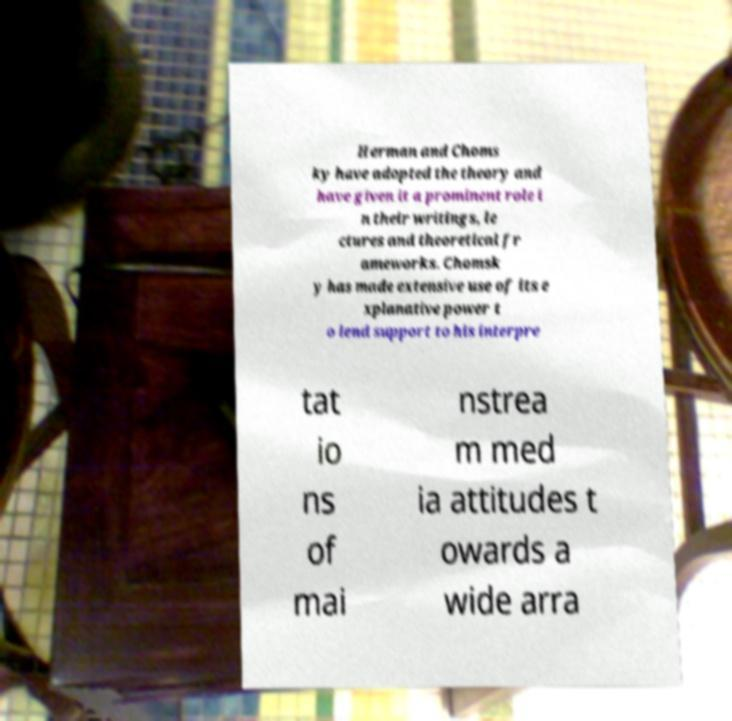Can you read and provide the text displayed in the image?This photo seems to have some interesting text. Can you extract and type it out for me? Herman and Choms ky have adopted the theory and have given it a prominent role i n their writings, le ctures and theoretical fr ameworks. Chomsk y has made extensive use of its e xplanative power t o lend support to his interpre tat io ns of mai nstrea m med ia attitudes t owards a wide arra 